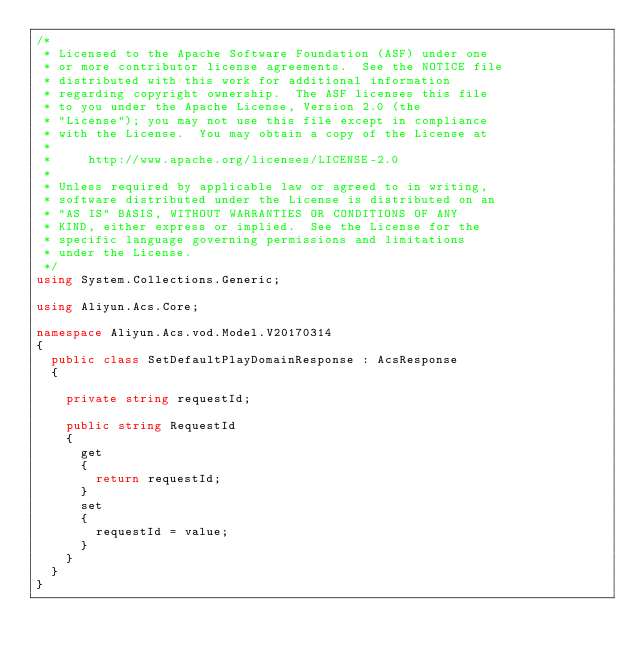<code> <loc_0><loc_0><loc_500><loc_500><_C#_>/*
 * Licensed to the Apache Software Foundation (ASF) under one
 * or more contributor license agreements.  See the NOTICE file
 * distributed with this work for additional information
 * regarding copyright ownership.  The ASF licenses this file
 * to you under the Apache License, Version 2.0 (the
 * "License"); you may not use this file except in compliance
 * with the License.  You may obtain a copy of the License at
 *
 *     http://www.apache.org/licenses/LICENSE-2.0
 *
 * Unless required by applicable law or agreed to in writing,
 * software distributed under the License is distributed on an
 * "AS IS" BASIS, WITHOUT WARRANTIES OR CONDITIONS OF ANY
 * KIND, either express or implied.  See the License for the
 * specific language governing permissions and limitations
 * under the License.
 */
using System.Collections.Generic;

using Aliyun.Acs.Core;

namespace Aliyun.Acs.vod.Model.V20170314
{
	public class SetDefaultPlayDomainResponse : AcsResponse
	{

		private string requestId;

		public string RequestId
		{
			get
			{
				return requestId;
			}
			set	
			{
				requestId = value;
			}
		}
	}
}
</code> 